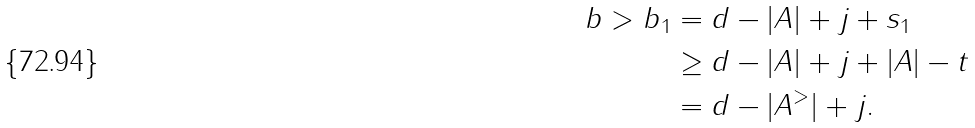<formula> <loc_0><loc_0><loc_500><loc_500>b > b _ { 1 } & = d - | A | + j + s _ { 1 } \\ & \geq d - | A | + j + | A | - t \\ & = d - | A ^ { > } | + j .</formula> 